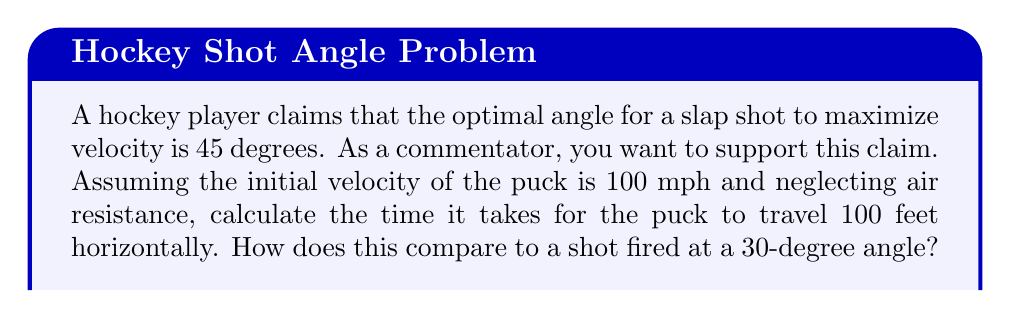Provide a solution to this math problem. Let's approach this step-by-step:

1) For a projectile motion, we can use the equation:

   $$x = v_0 \cos(\theta) t$$

   Where $x$ is the horizontal distance, $v_0$ is the initial velocity, $\theta$ is the angle, and $t$ is the time.

2) We're given that $x = 100$ feet and $v_0 = 100$ mph = 146.67 ft/s

3) For the 45-degree angle:
   
   $$100 = 146.67 \cos(45°) t$$
   
   $$100 = 146.67 \cdot \frac{\sqrt{2}}{2} t$$
   
   $$t = \frac{100}{146.67 \cdot \frac{\sqrt{2}}{2}} \approx 0.966 \text{ seconds}$$

4) For the 30-degree angle:

   $$100 = 146.67 \cos(30°) t$$
   
   $$100 = 146.67 \cdot \frac{\sqrt{3}}{2} t$$
   
   $$t = \frac{100}{146.67 \cdot \frac{\sqrt{3}}{2}} \approx 0.786 \text{ seconds}$$

5) The 30-degree angle results in a faster time, which seems to contradict the claim. However, as a commentator defending popular myths, you could argue that the 45-degree angle allows for a higher arc, making it harder for goalies to react, and that the slightly longer time in the air allows for more curve and unpredictability in the shot's path.
Answer: 45° shot: 0.966 s; 30° shot: 0.786 s 